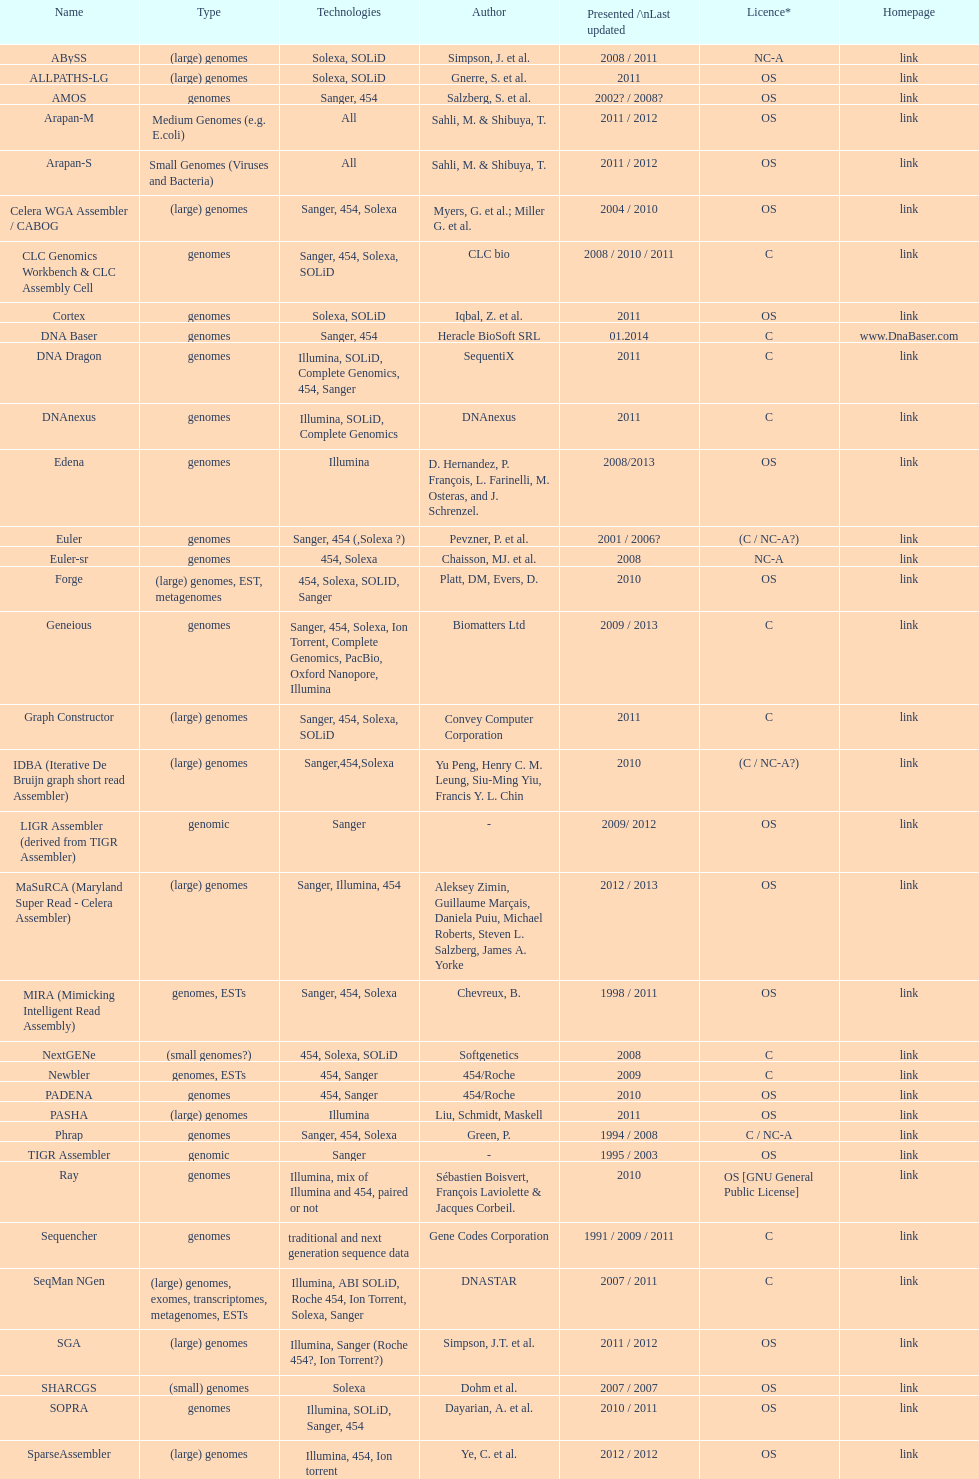What is the aggregate amount of assemblers for medium genome type technologies? 1. 